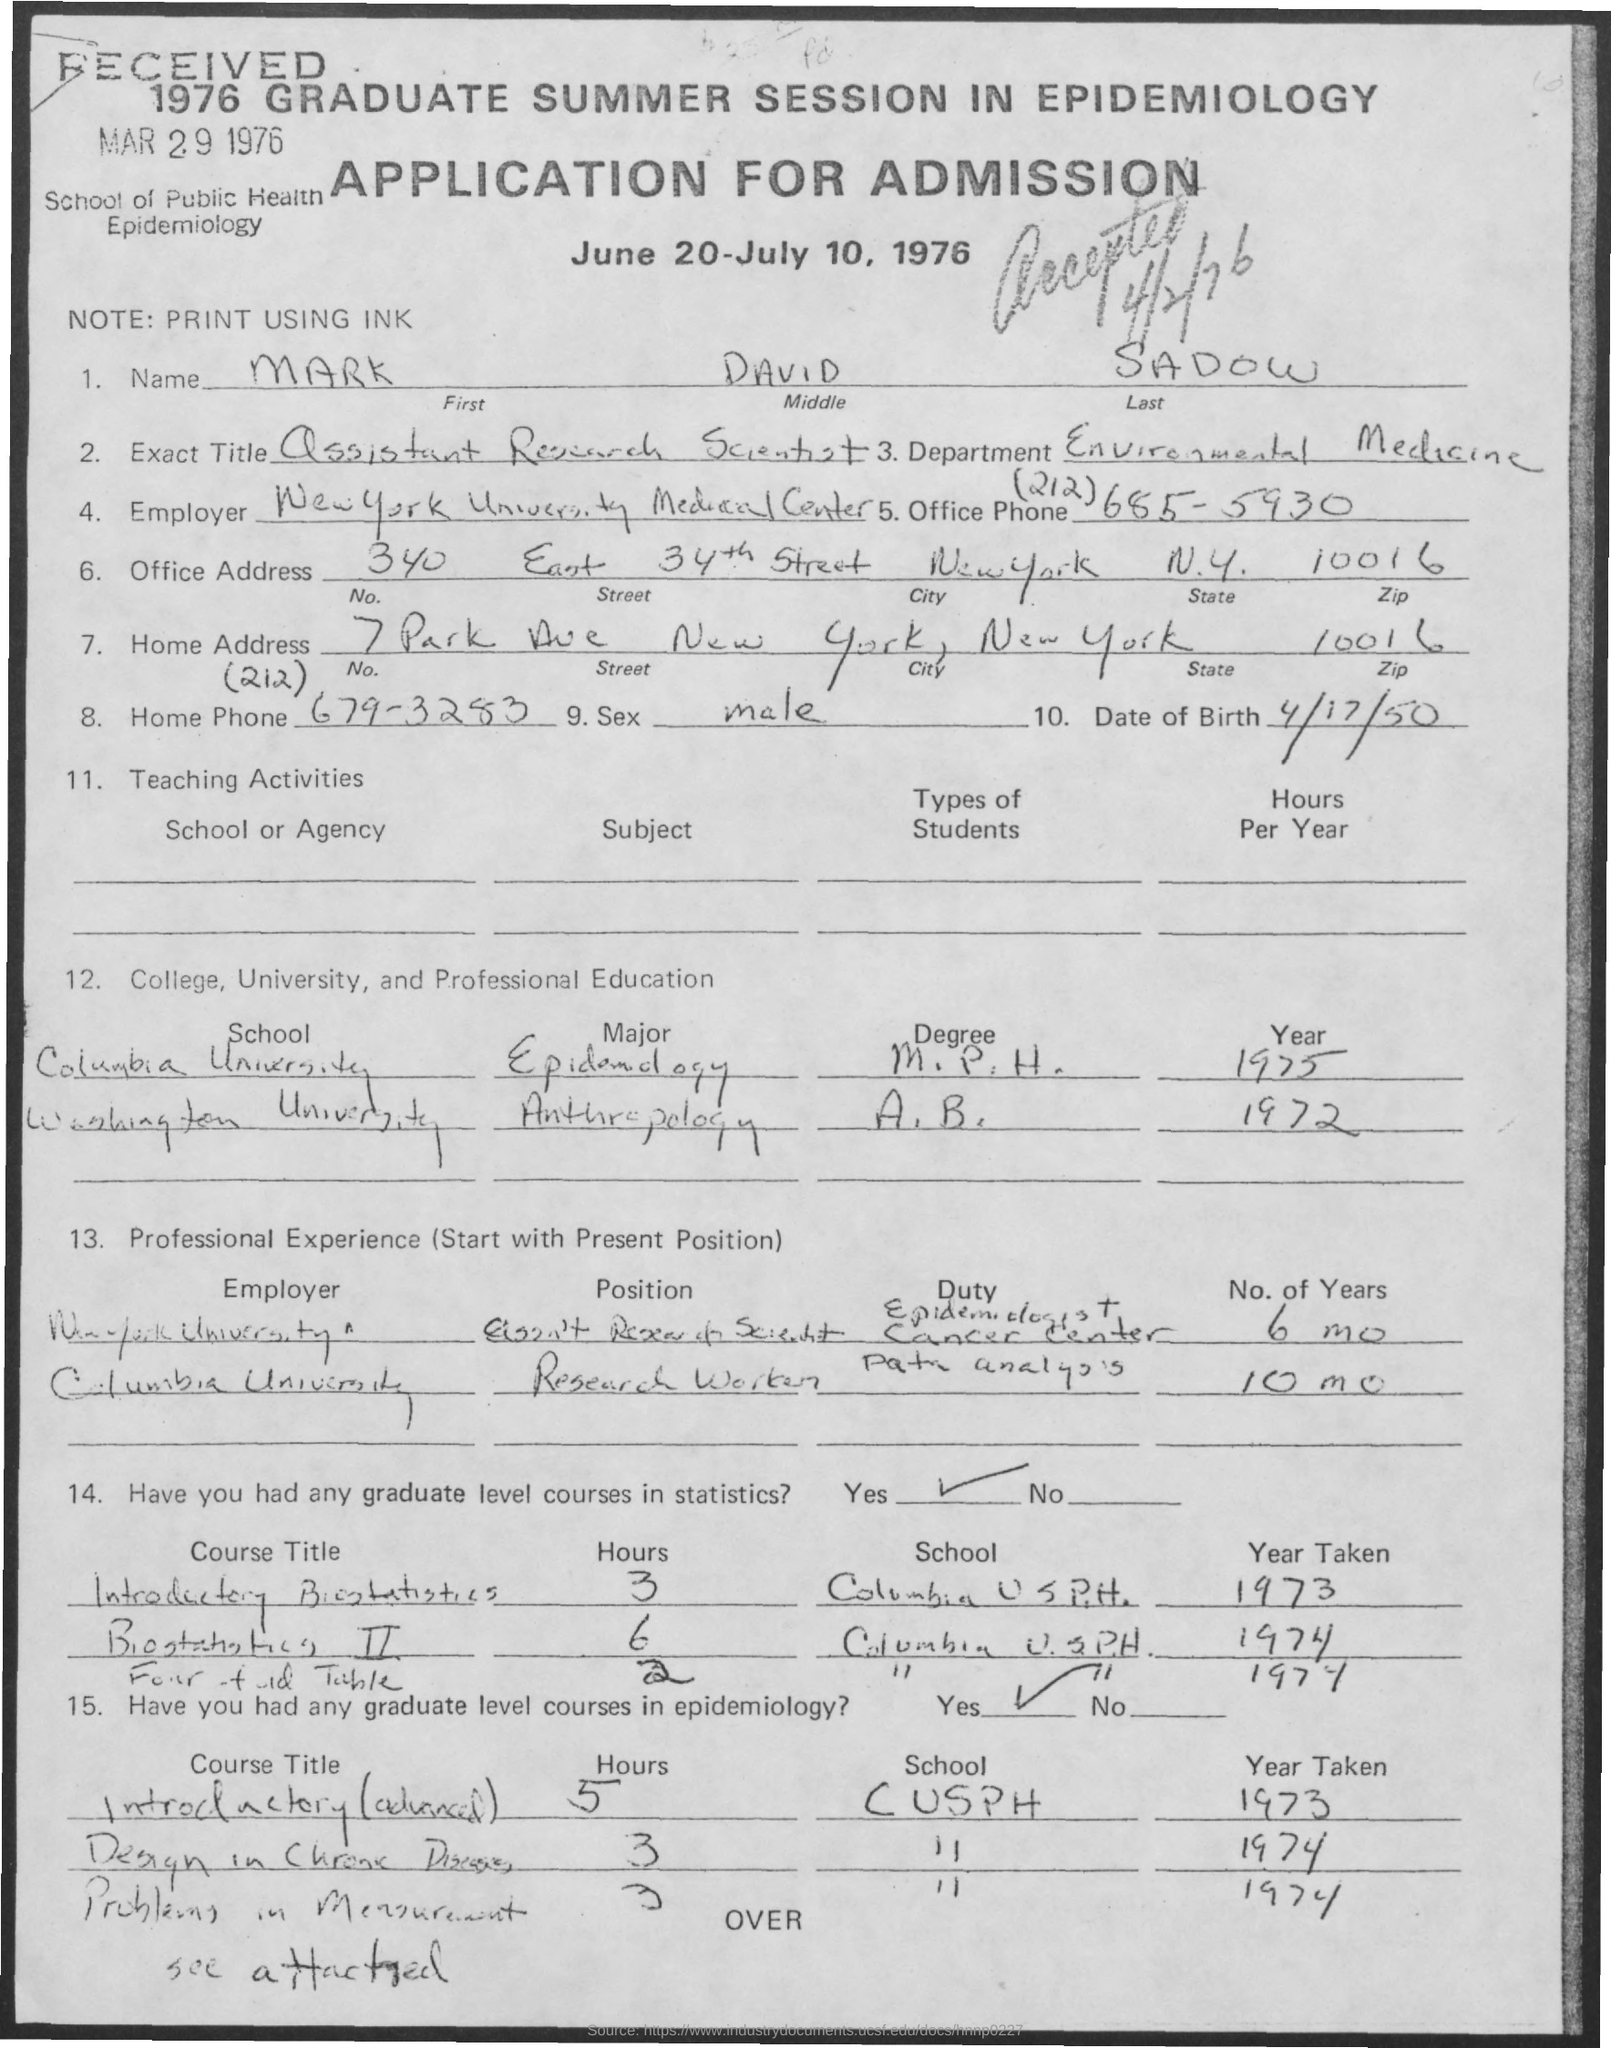List a handful of essential elements in this visual. The memorandum contains the name "Mark David Sadow. The date of birth of Mark is April 17, 1950. 